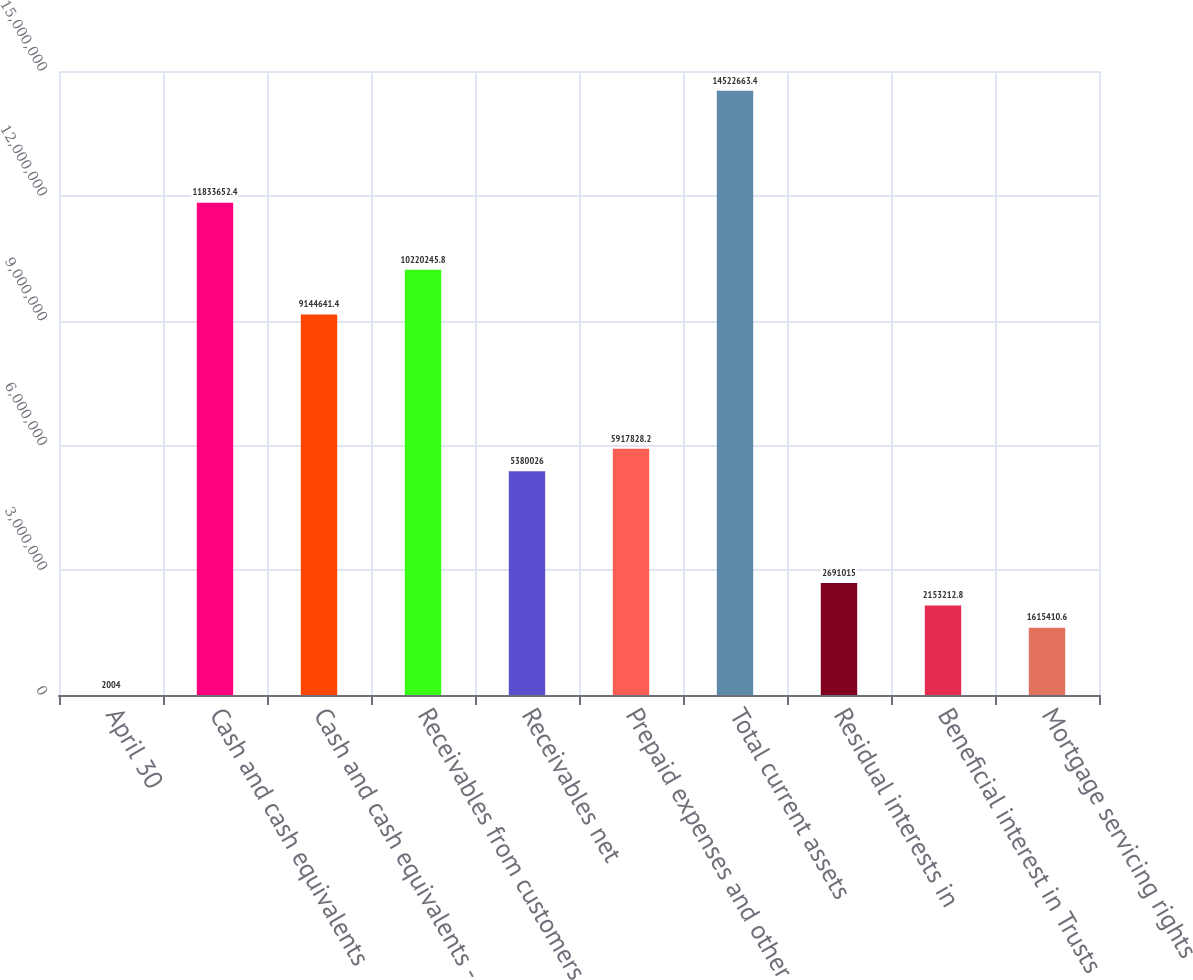Convert chart. <chart><loc_0><loc_0><loc_500><loc_500><bar_chart><fcel>April 30<fcel>Cash and cash equivalents<fcel>Cash and cash equivalents -<fcel>Receivables from customers<fcel>Receivables net<fcel>Prepaid expenses and other<fcel>Total current assets<fcel>Residual interests in<fcel>Beneficial interest in Trusts<fcel>Mortgage servicing rights<nl><fcel>2004<fcel>1.18337e+07<fcel>9.14464e+06<fcel>1.02202e+07<fcel>5.38003e+06<fcel>5.91783e+06<fcel>1.45227e+07<fcel>2.69102e+06<fcel>2.15321e+06<fcel>1.61541e+06<nl></chart> 